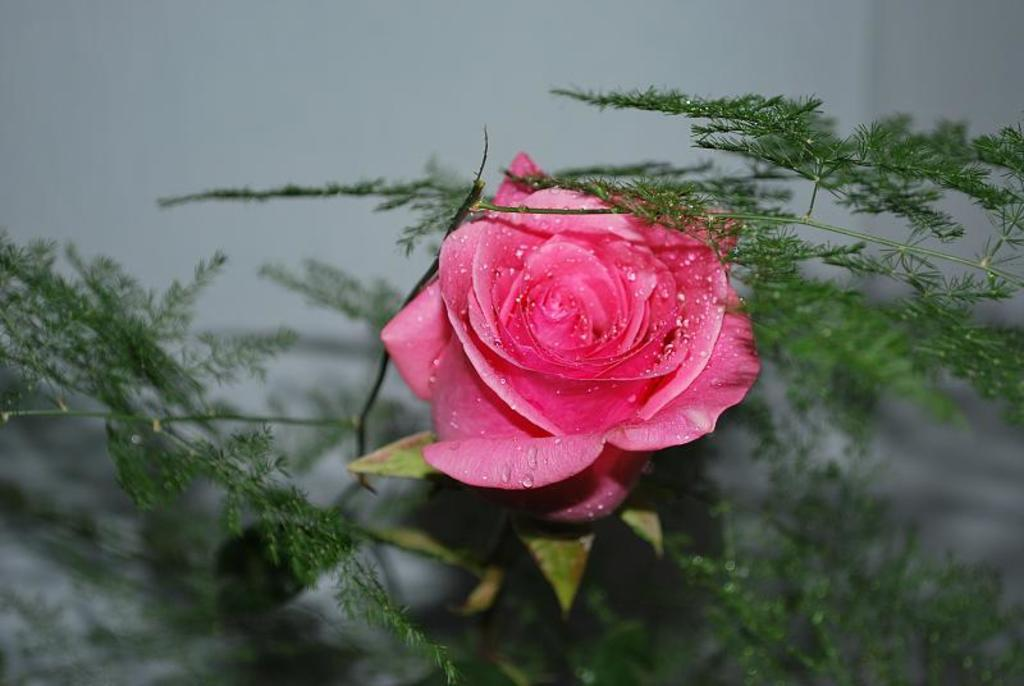What type of flower is in the image? There is a pink rose flower in the image. Where is the flower located? The flower is on a plant. What else can be seen in the foreground of the image? There are other plants in the foreground of the image. What is present on the flower? There are water droplets on the flower. What is visible in the background of the image? There is a wall in the background of the image. What type of hat is the flower wearing in the image? There is no hat present on the flower in the image. 